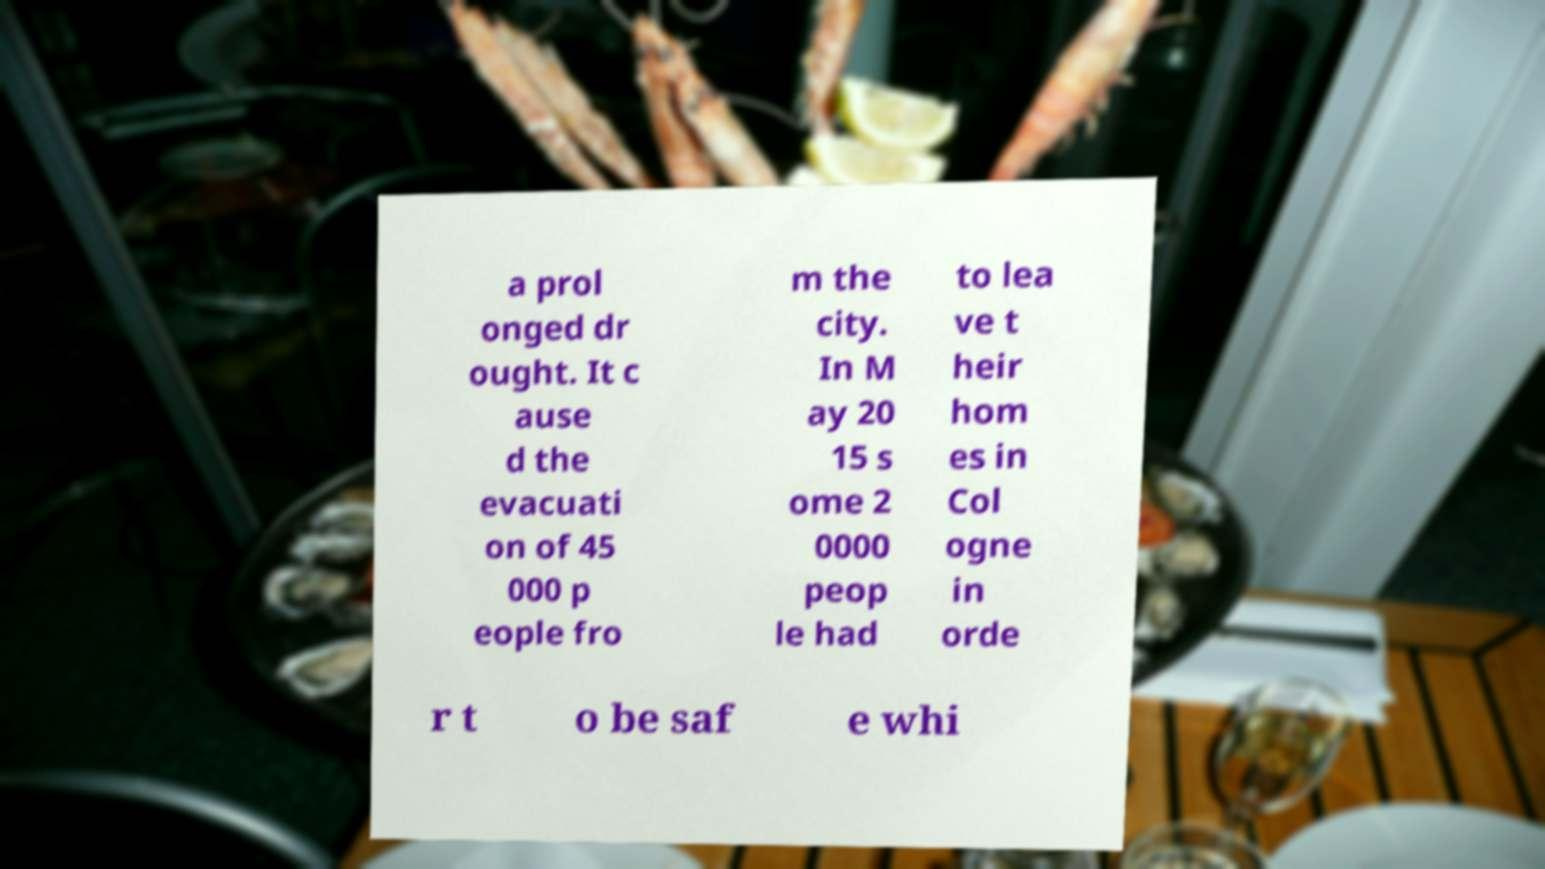I need the written content from this picture converted into text. Can you do that? a prol onged dr ought. It c ause d the evacuati on of 45 000 p eople fro m the city. In M ay 20 15 s ome 2 0000 peop le had to lea ve t heir hom es in Col ogne in orde r t o be saf e whi 